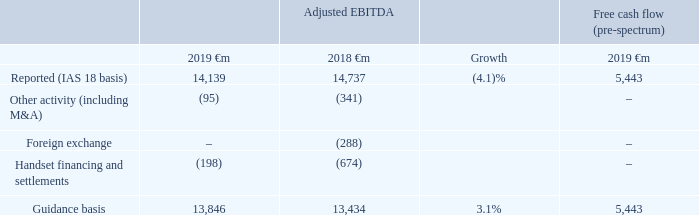2019 financial year guidance
The adjusted EBITDA and free cash flow guidance measures for the year ended 31 March 2019 were forward-looking alternative performance measures based on the Group’s assessment of the global macroeconomic outlook and foreign exchange rates of €1:£0.87, €1:ZAR 15.1, €1:TRY 5.1 and €1:EGP 22.1. These guidance measures exclude the impact of licence and spectrum payments, material one-off tax-related payments, restructuring payments, changes in shareholder recharges from India and any fundamental structural change to the Eurozone. They also assume no material change to the current structure of the Group. We believe it is both useful and necessary to report these guidance measures to give investors an indication of the Group’s expected future performance, the Group’s sensitivity to foreign exchange movements and to report actual performance against these guidance measures.
Reconciliations of adjusted EBITDA and free cash flow to the 2019 financial year guidance basis is shown below.
What financial items does guidance basis comprise of? Reported (ias 18 basis), other activity (including m&a), foreign exchange, handset financing and settlements. Which financial years' information is shown in the table? 2018, 2019. What does the table show? Reconciliations of adjusted ebitda and free cash flow to the 2019 financial year guidance basis. Between 2018 and 2019, which year has higher adjusted EBITDA, reported (IAS 18 basis)? 14,737>14,139
Answer: 2018. Between 2018 and 2019, which year had higher adjusted EBITDA, guidance basis? 13,846>13,434
Answer: 2019. What is the 2019 average adjusted EBITDA, guidance basis?
Answer scale should be: million. (13,846+13,434)/2
Answer: 13640. 